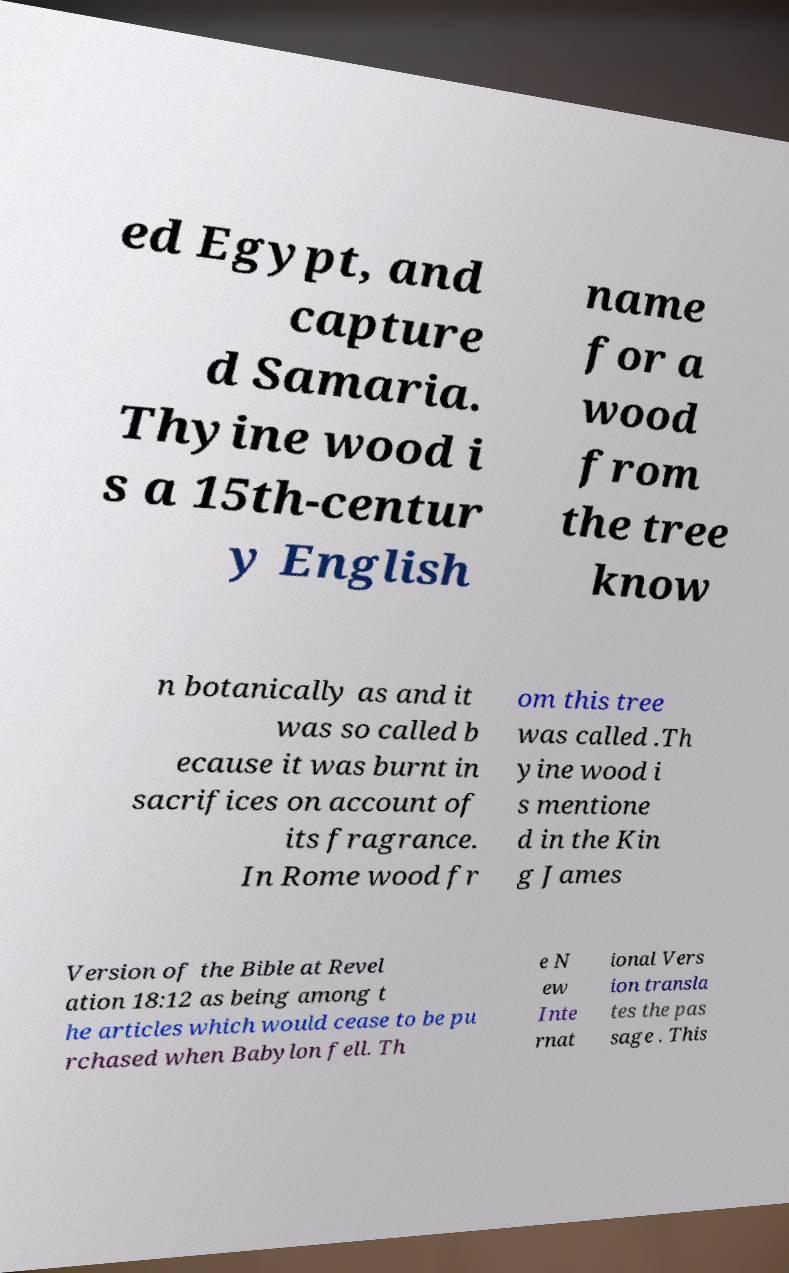What messages or text are displayed in this image? I need them in a readable, typed format. ed Egypt, and capture d Samaria. Thyine wood i s a 15th-centur y English name for a wood from the tree know n botanically as and it was so called b ecause it was burnt in sacrifices on account of its fragrance. In Rome wood fr om this tree was called .Th yine wood i s mentione d in the Kin g James Version of the Bible at Revel ation 18:12 as being among t he articles which would cease to be pu rchased when Babylon fell. Th e N ew Inte rnat ional Vers ion transla tes the pas sage . This 